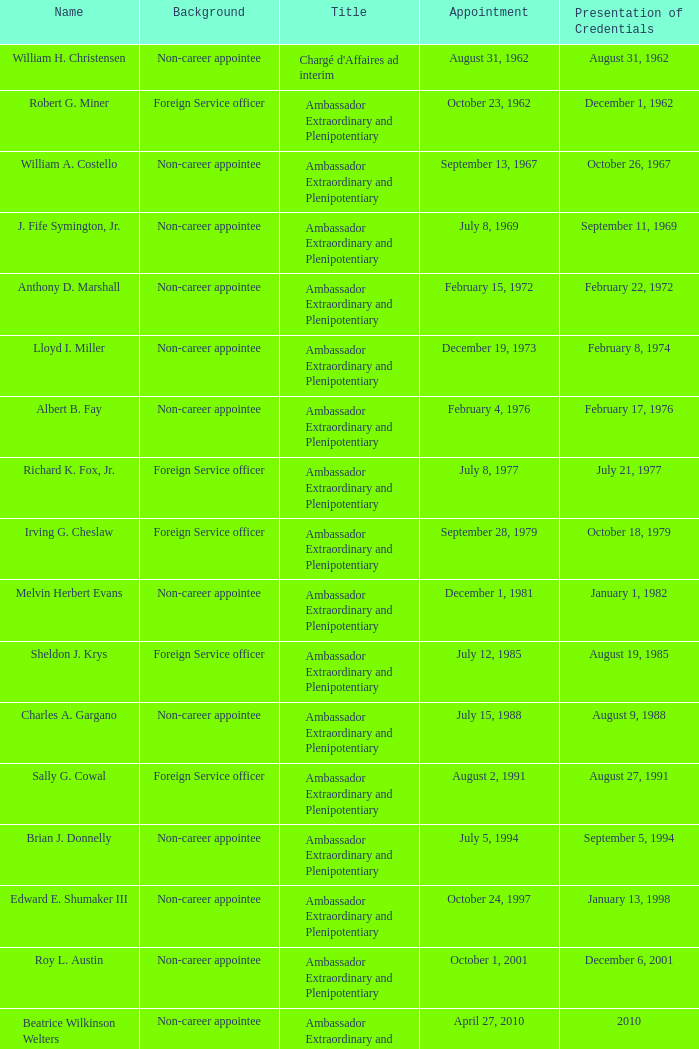What was the designation of anthony d. marshall? Ambassador Extraordinary and Plenipotentiary. 